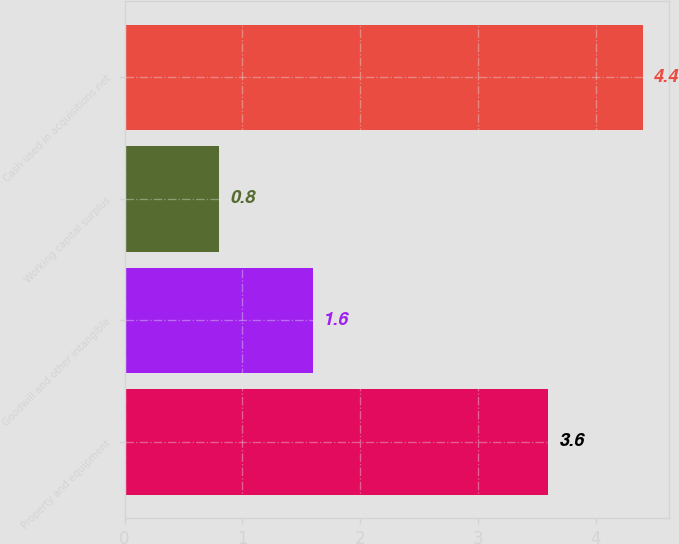<chart> <loc_0><loc_0><loc_500><loc_500><bar_chart><fcel>Property and equipment<fcel>Goodwill and other intangible<fcel>Working capital surplus<fcel>Cash used in acquisitions net<nl><fcel>3.6<fcel>1.6<fcel>0.8<fcel>4.4<nl></chart> 